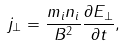<formula> <loc_0><loc_0><loc_500><loc_500>j _ { \perp } = \frac { m _ { i } n _ { i } } { B ^ { 2 } } \frac { \partial E _ { \perp } } { \partial t } ,</formula> 